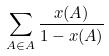Convert formula to latex. <formula><loc_0><loc_0><loc_500><loc_500>\sum _ { A \in A } \frac { x ( A ) } { 1 - x ( A ) }</formula> 